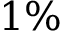<formula> <loc_0><loc_0><loc_500><loc_500>1 \%</formula> 